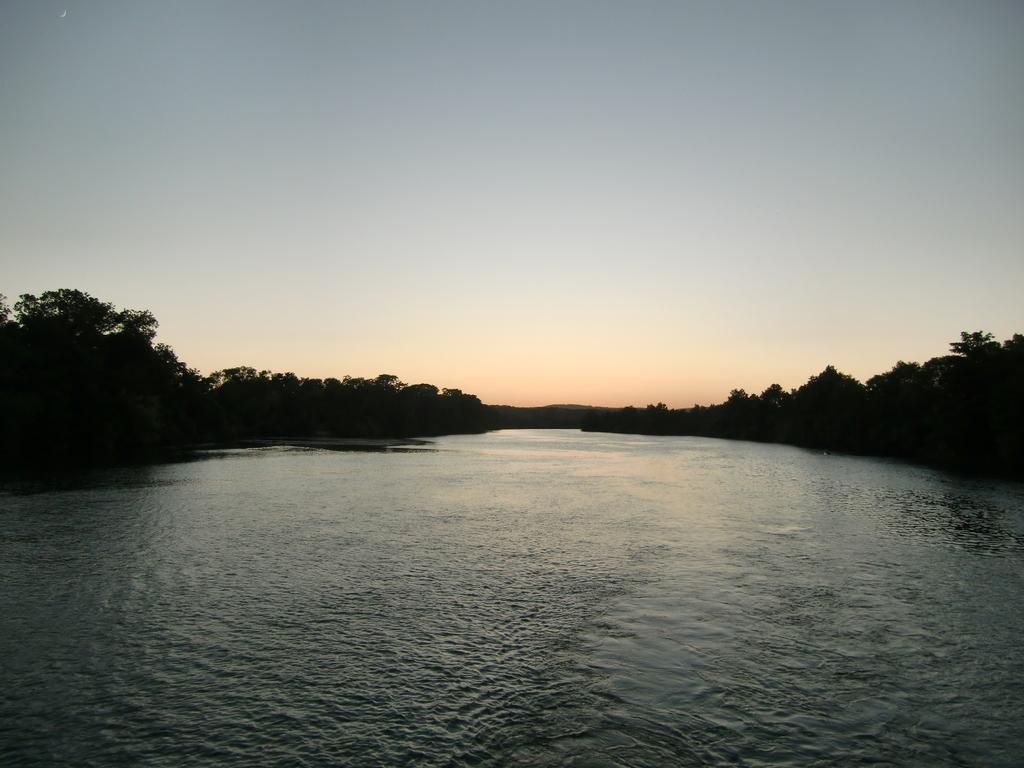In one or two sentences, can you explain what this image depicts? In this picture, we can see water, trees, and the sky. 